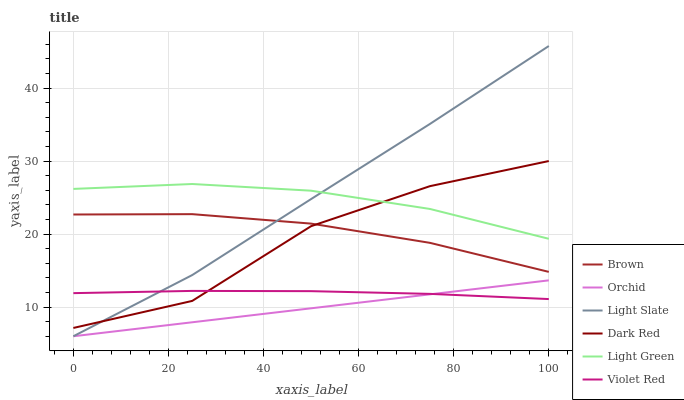Does Orchid have the minimum area under the curve?
Answer yes or no. Yes. Does Light Slate have the maximum area under the curve?
Answer yes or no. Yes. Does Violet Red have the minimum area under the curve?
Answer yes or no. No. Does Violet Red have the maximum area under the curve?
Answer yes or no. No. Is Orchid the smoothest?
Answer yes or no. Yes. Is Dark Red the roughest?
Answer yes or no. Yes. Is Violet Red the smoothest?
Answer yes or no. No. Is Violet Red the roughest?
Answer yes or no. No. Does Light Slate have the lowest value?
Answer yes or no. Yes. Does Violet Red have the lowest value?
Answer yes or no. No. Does Light Slate have the highest value?
Answer yes or no. Yes. Does Violet Red have the highest value?
Answer yes or no. No. Is Brown less than Light Green?
Answer yes or no. Yes. Is Dark Red greater than Orchid?
Answer yes or no. Yes. Does Light Green intersect Light Slate?
Answer yes or no. Yes. Is Light Green less than Light Slate?
Answer yes or no. No. Is Light Green greater than Light Slate?
Answer yes or no. No. Does Brown intersect Light Green?
Answer yes or no. No. 